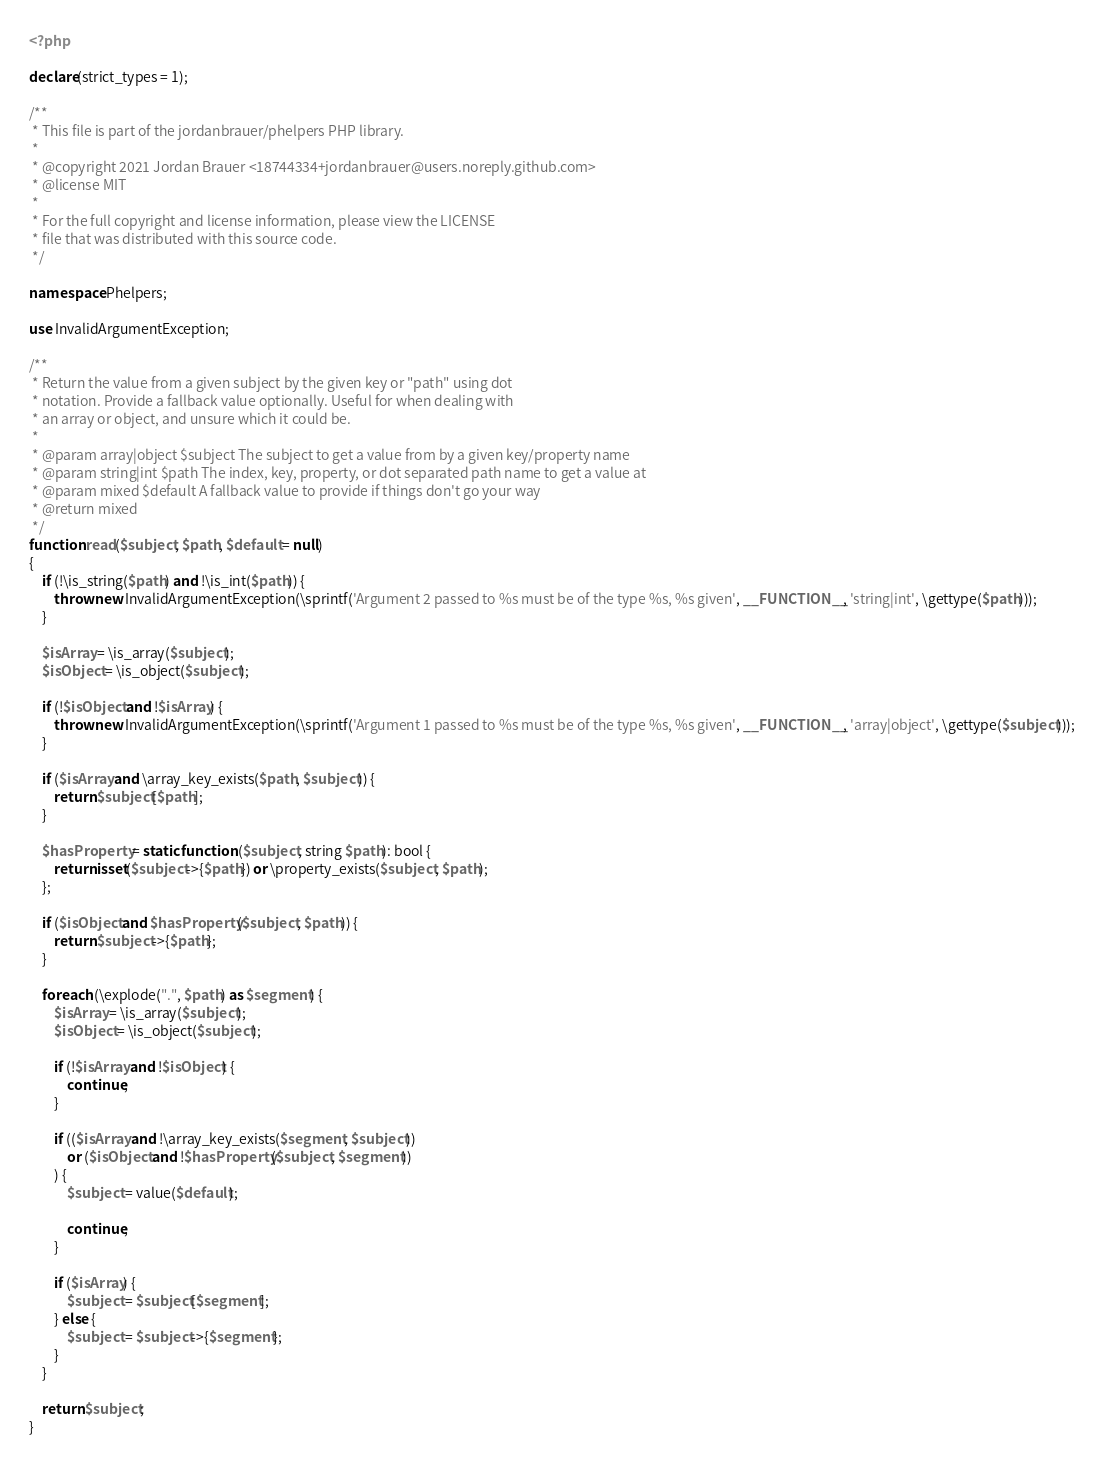<code> <loc_0><loc_0><loc_500><loc_500><_PHP_><?php

declare(strict_types = 1);

/**
 * This file is part of the jordanbrauer/phelpers PHP library.
 *
 * @copyright 2021 Jordan Brauer <18744334+jordanbrauer@users.noreply.github.com>
 * @license MIT
 *
 * For the full copyright and license information, please view the LICENSE
 * file that was distributed with this source code.
 */

namespace Phelpers;

use InvalidArgumentException;

/**
 * Return the value from a given subject by the given key or "path" using dot
 * notation. Provide a fallback value optionally. Useful for when dealing with
 * an array or object, and unsure which it could be.
 *
 * @param array|object $subject The subject to get a value from by a given key/property name
 * @param string|int $path The index, key, property, or dot separated path name to get a value at
 * @param mixed $default A fallback value to provide if things don't go your way
 * @return mixed
 */
function read($subject, $path, $default = null)
{
    if (!\is_string($path) and !\is_int($path)) {
        throw new InvalidArgumentException(\sprintf('Argument 2 passed to %s must be of the type %s, %s given', __FUNCTION__, 'string|int', \gettype($path)));
    }

    $isArray = \is_array($subject);
    $isObject = \is_object($subject);

    if (!$isObject and !$isArray) {
        throw new InvalidArgumentException(\sprintf('Argument 1 passed to %s must be of the type %s, %s given', __FUNCTION__, 'array|object', \gettype($subject)));
    }

    if ($isArray and \array_key_exists($path, $subject)) {
        return $subject[$path];
    }

    $hasProperty = static function ($subject, string $path): bool {
        return isset($subject->{$path}) or \property_exists($subject, $path);
    };

    if ($isObject and $hasProperty($subject, $path)) {
        return $subject->{$path};
    }

    foreach (\explode(".", $path) as $segment) {
        $isArray = \is_array($subject);
        $isObject = \is_object($subject);

        if (!$isArray and !$isObject) {
            continue;
        }

        if (($isArray and !\array_key_exists($segment, $subject))
            or ($isObject and !$hasProperty($subject, $segment))
        ) {
            $subject = value($default);

            continue;
        }

        if ($isArray) {
            $subject = $subject[$segment];
        } else {
            $subject = $subject->{$segment};
        }
    }

    return $subject;
}
</code> 